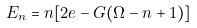Convert formula to latex. <formula><loc_0><loc_0><loc_500><loc_500>E _ { n } = n [ 2 e - G ( \Omega - n + 1 ) ]</formula> 